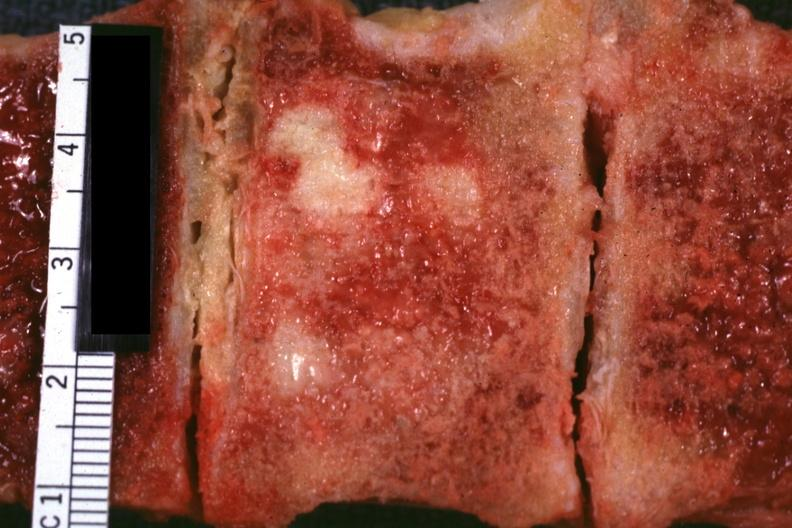how is very close-up view excellent vertebral body primary prostate?
Answer the question using a single word or phrase. Adenocarcinoma 